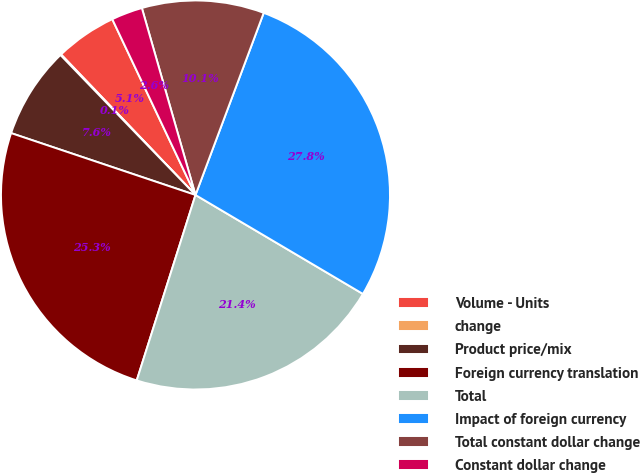Convert chart. <chart><loc_0><loc_0><loc_500><loc_500><pie_chart><fcel>Volume - Units<fcel>change<fcel>Product price/mix<fcel>Foreign currency translation<fcel>Total<fcel>Impact of foreign currency<fcel>Total constant dollar change<fcel>Constant dollar change<nl><fcel>5.11%<fcel>0.07%<fcel>7.63%<fcel>25.27%<fcel>21.39%<fcel>27.79%<fcel>10.15%<fcel>2.59%<nl></chart> 